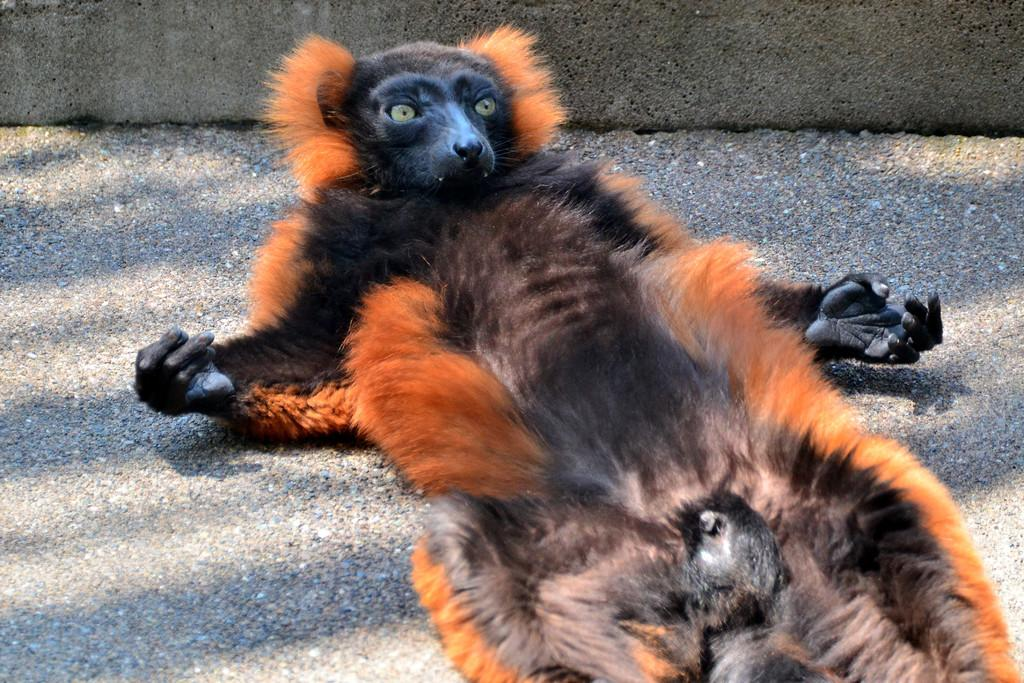What type of creature is present in the image? There is an animal in the image. Where is the animal located? The animal is on the road. What colors can be seen on the animal? The animal has orange and black coloring. What type of wool can be seen on the animal in the image? There is no wool present on the animal in the image. Can you describe the animal's attempt to cross the road in the image? The image does not show the animal attempting to cross the road; it only shows the animal on the road. 